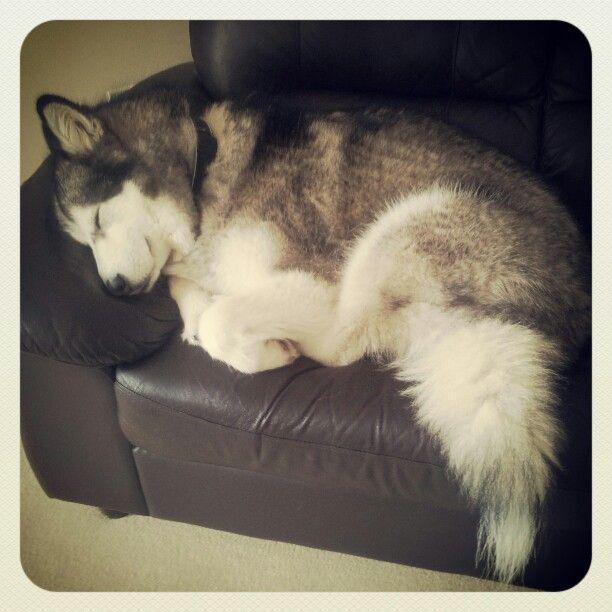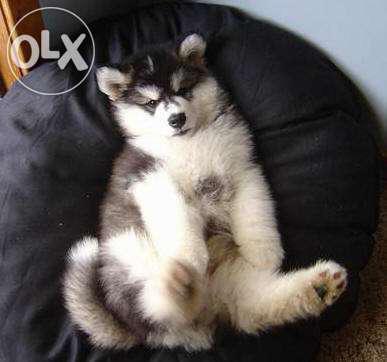The first image is the image on the left, the second image is the image on the right. Evaluate the accuracy of this statement regarding the images: "The left image shows one husky dog reclining with its nose pointed leftward, and the right image shows some type of animal with its head on top of a reclining husky.". Is it true? Answer yes or no. No. The first image is the image on the left, the second image is the image on the right. Evaluate the accuracy of this statement regarding the images: "There is exactly one dog that is sleeping in each image.". Is it true? Answer yes or no. Yes. 